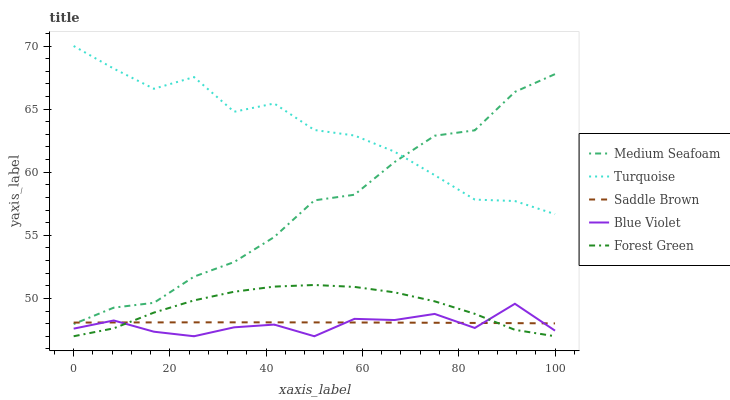Does Blue Violet have the minimum area under the curve?
Answer yes or no. Yes. Does Turquoise have the maximum area under the curve?
Answer yes or no. Yes. Does Medium Seafoam have the minimum area under the curve?
Answer yes or no. No. Does Medium Seafoam have the maximum area under the curve?
Answer yes or no. No. Is Saddle Brown the smoothest?
Answer yes or no. Yes. Is Turquoise the roughest?
Answer yes or no. Yes. Is Medium Seafoam the smoothest?
Answer yes or no. No. Is Medium Seafoam the roughest?
Answer yes or no. No. Does Forest Green have the lowest value?
Answer yes or no. Yes. Does Medium Seafoam have the lowest value?
Answer yes or no. No. Does Turquoise have the highest value?
Answer yes or no. Yes. Does Medium Seafoam have the highest value?
Answer yes or no. No. Is Blue Violet less than Turquoise?
Answer yes or no. Yes. Is Turquoise greater than Saddle Brown?
Answer yes or no. Yes. Does Forest Green intersect Saddle Brown?
Answer yes or no. Yes. Is Forest Green less than Saddle Brown?
Answer yes or no. No. Is Forest Green greater than Saddle Brown?
Answer yes or no. No. Does Blue Violet intersect Turquoise?
Answer yes or no. No. 